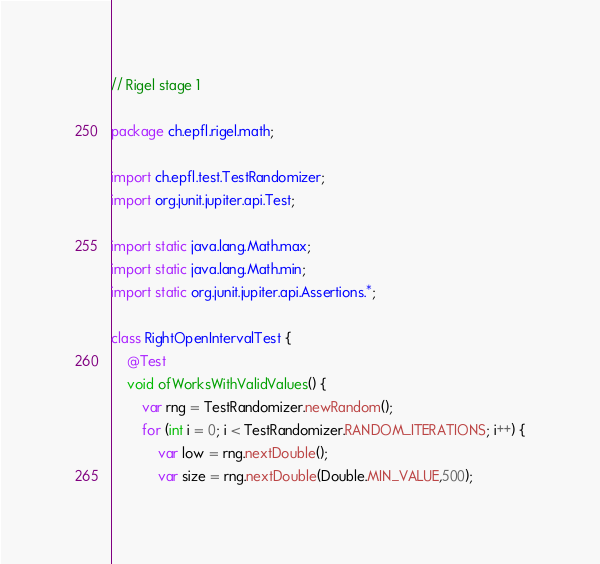<code> <loc_0><loc_0><loc_500><loc_500><_Java_>// Rigel stage 1

package ch.epfl.rigel.math;

import ch.epfl.test.TestRandomizer;
import org.junit.jupiter.api.Test;

import static java.lang.Math.max;
import static java.lang.Math.min;
import static org.junit.jupiter.api.Assertions.*;

class RightOpenIntervalTest {
    @Test
    void ofWorksWithValidValues() {
        var rng = TestRandomizer.newRandom();
        for (int i = 0; i < TestRandomizer.RANDOM_ITERATIONS; i++) {
            var low = rng.nextDouble();
            var size = rng.nextDouble(Double.MIN_VALUE,500);</code> 